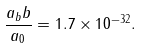Convert formula to latex. <formula><loc_0><loc_0><loc_500><loc_500>\frac { a _ { b } b } { a _ { 0 } } = 1 . 7 \times 1 0 ^ { - 3 2 } .</formula> 